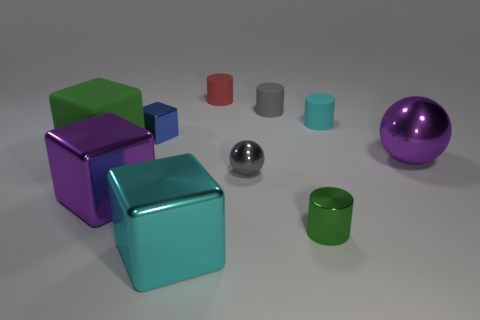Subtract 1 cylinders. How many cylinders are left? 3 Subtract all balls. How many objects are left? 8 Add 5 cyan metal things. How many cyan metal things exist? 6 Subtract 0 blue cylinders. How many objects are left? 10 Subtract all cyan spheres. Subtract all small metal blocks. How many objects are left? 9 Add 8 small gray cylinders. How many small gray cylinders are left? 9 